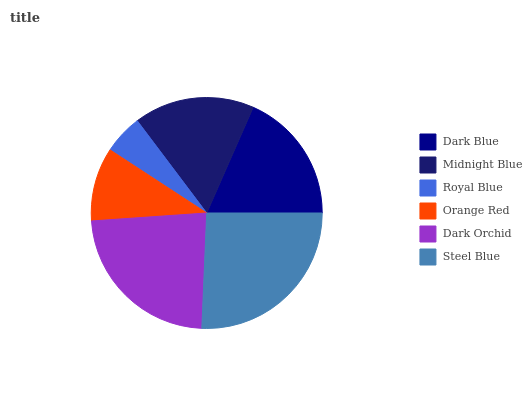Is Royal Blue the minimum?
Answer yes or no. Yes. Is Steel Blue the maximum?
Answer yes or no. Yes. Is Midnight Blue the minimum?
Answer yes or no. No. Is Midnight Blue the maximum?
Answer yes or no. No. Is Dark Blue greater than Midnight Blue?
Answer yes or no. Yes. Is Midnight Blue less than Dark Blue?
Answer yes or no. Yes. Is Midnight Blue greater than Dark Blue?
Answer yes or no. No. Is Dark Blue less than Midnight Blue?
Answer yes or no. No. Is Dark Blue the high median?
Answer yes or no. Yes. Is Midnight Blue the low median?
Answer yes or no. Yes. Is Midnight Blue the high median?
Answer yes or no. No. Is Orange Red the low median?
Answer yes or no. No. 